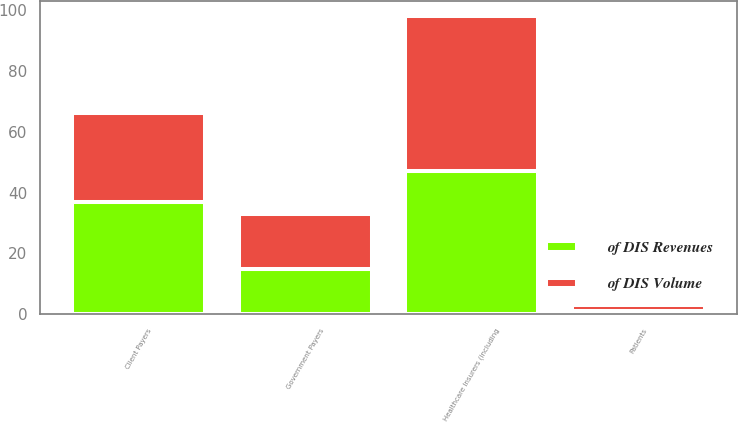<chart> <loc_0><loc_0><loc_500><loc_500><stacked_bar_chart><ecel><fcel>Healthcare Insurers (including<fcel>Government Payers<fcel>Client Payers<fcel>Patients<nl><fcel>of DIS Revenues<fcel>47<fcel>15<fcel>37<fcel>1<nl><fcel>of DIS Volume<fcel>51<fcel>18<fcel>29<fcel>2<nl></chart> 